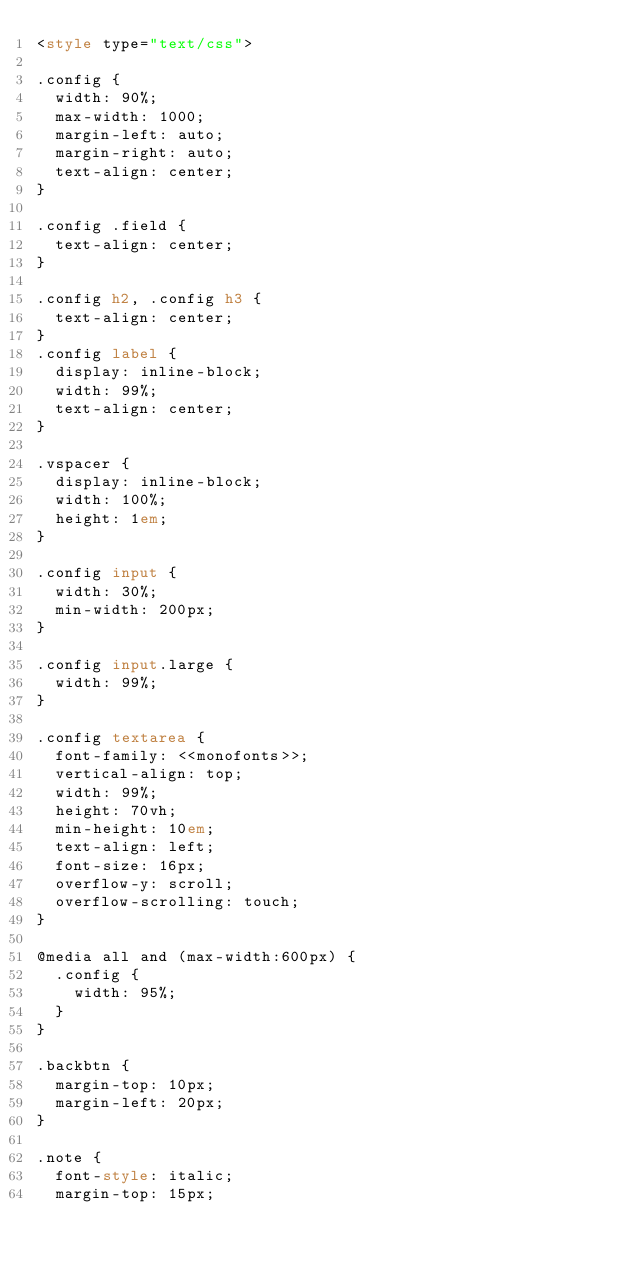Convert code to text. <code><loc_0><loc_0><loc_500><loc_500><_HTML_><style type="text/css">

.config {
	width: 90%;
	max-width: 1000;
	margin-left: auto;
	margin-right: auto;
	text-align: center;
}

.config .field {
	text-align: center;
}

.config h2, .config h3 {
	text-align: center;
}
.config label {
	display: inline-block;
	width: 99%;
	text-align: center;
}

.vspacer {
	display: inline-block;
	width: 100%;
	height: 1em;
}

.config input {
	width: 30%;
	min-width: 200px;
}

.config input.large {
	width: 99%;
}

.config textarea {
	font-family: <<monofonts>>;
	vertical-align: top;
	width: 99%;
	height: 70vh;
	min-height: 10em;
	text-align: left;
	font-size: 16px;
	overflow-y: scroll;
	overflow-scrolling: touch;
}

@media all and (max-width:600px) {
	.config {
		width: 95%;
	}
}

.backbtn {
	margin-top: 10px;
	margin-left: 20px;
}

.note {
	font-style: italic;
	margin-top: 15px;</code> 